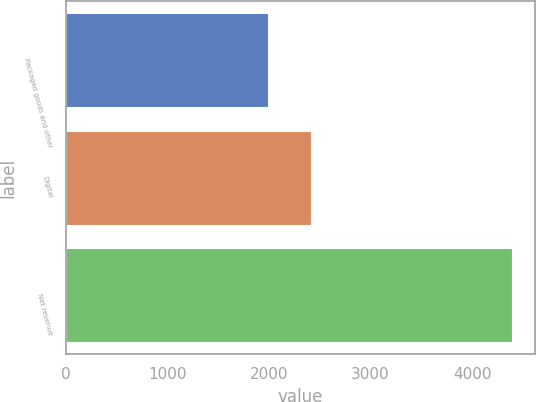Convert chart. <chart><loc_0><loc_0><loc_500><loc_500><bar_chart><fcel>Packaged goods and other<fcel>Digital<fcel>Net revenue<nl><fcel>1987<fcel>2409<fcel>4396<nl></chart> 